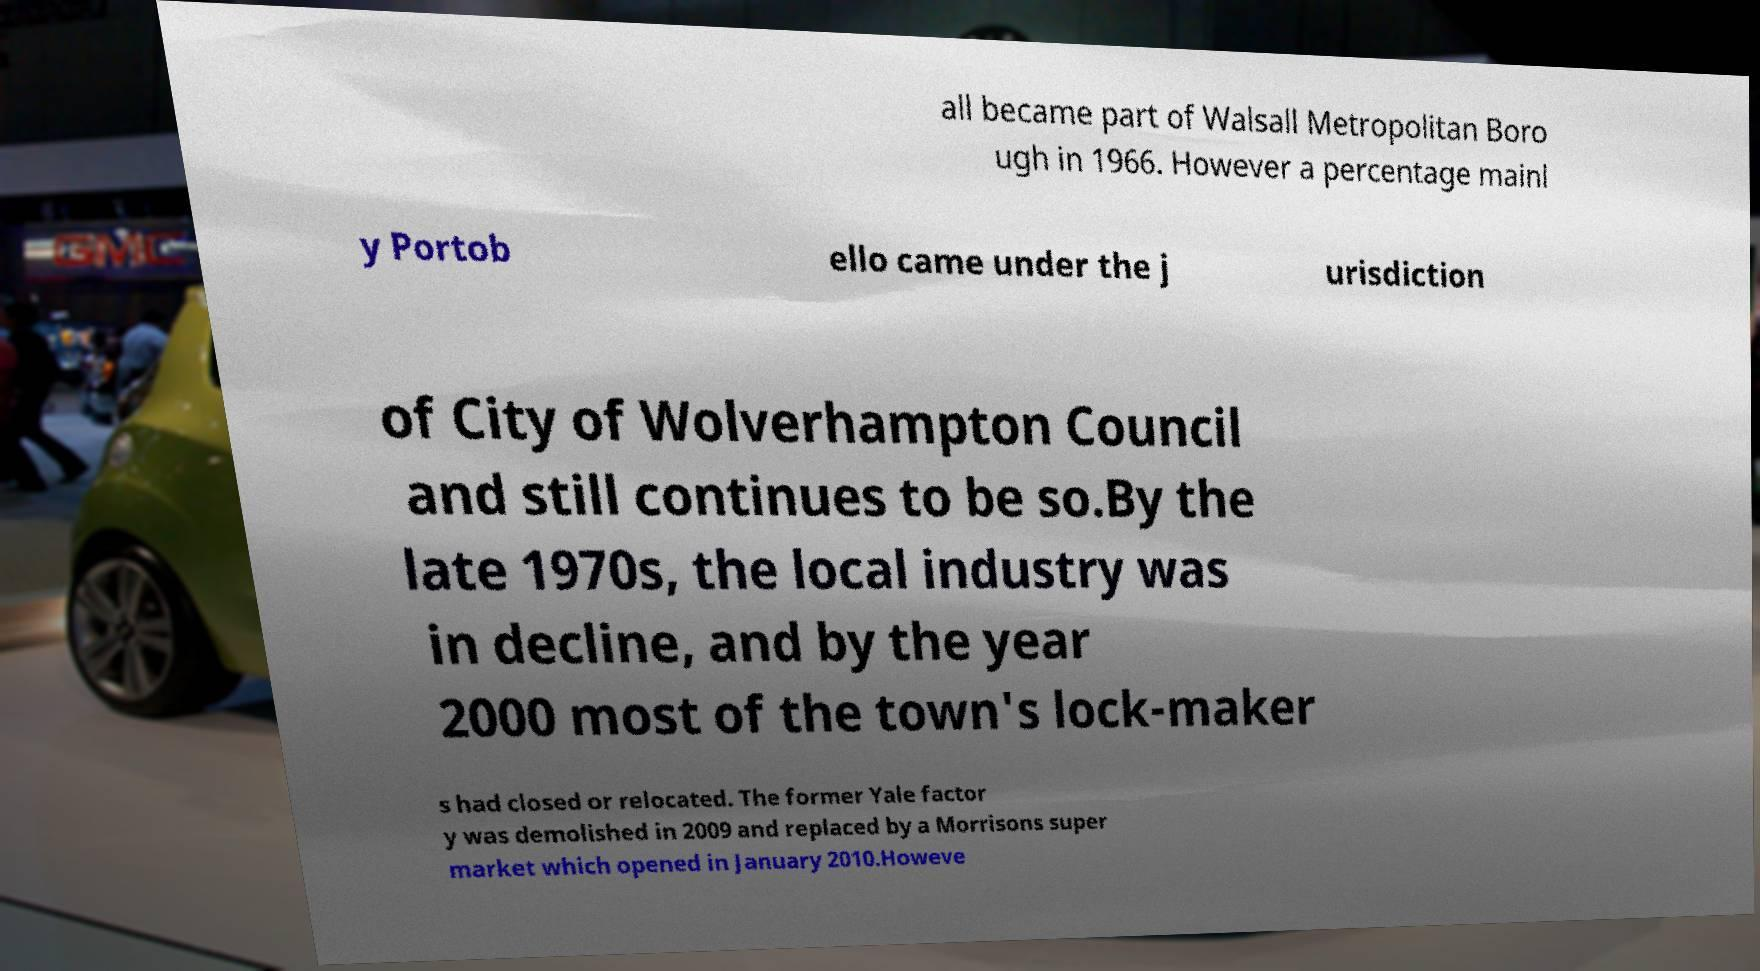Can you read and provide the text displayed in the image?This photo seems to have some interesting text. Can you extract and type it out for me? all became part of Walsall Metropolitan Boro ugh in 1966. However a percentage mainl y Portob ello came under the j urisdiction of City of Wolverhampton Council and still continues to be so.By the late 1970s, the local industry was in decline, and by the year 2000 most of the town's lock-maker s had closed or relocated. The former Yale factor y was demolished in 2009 and replaced by a Morrisons super market which opened in January 2010.Howeve 